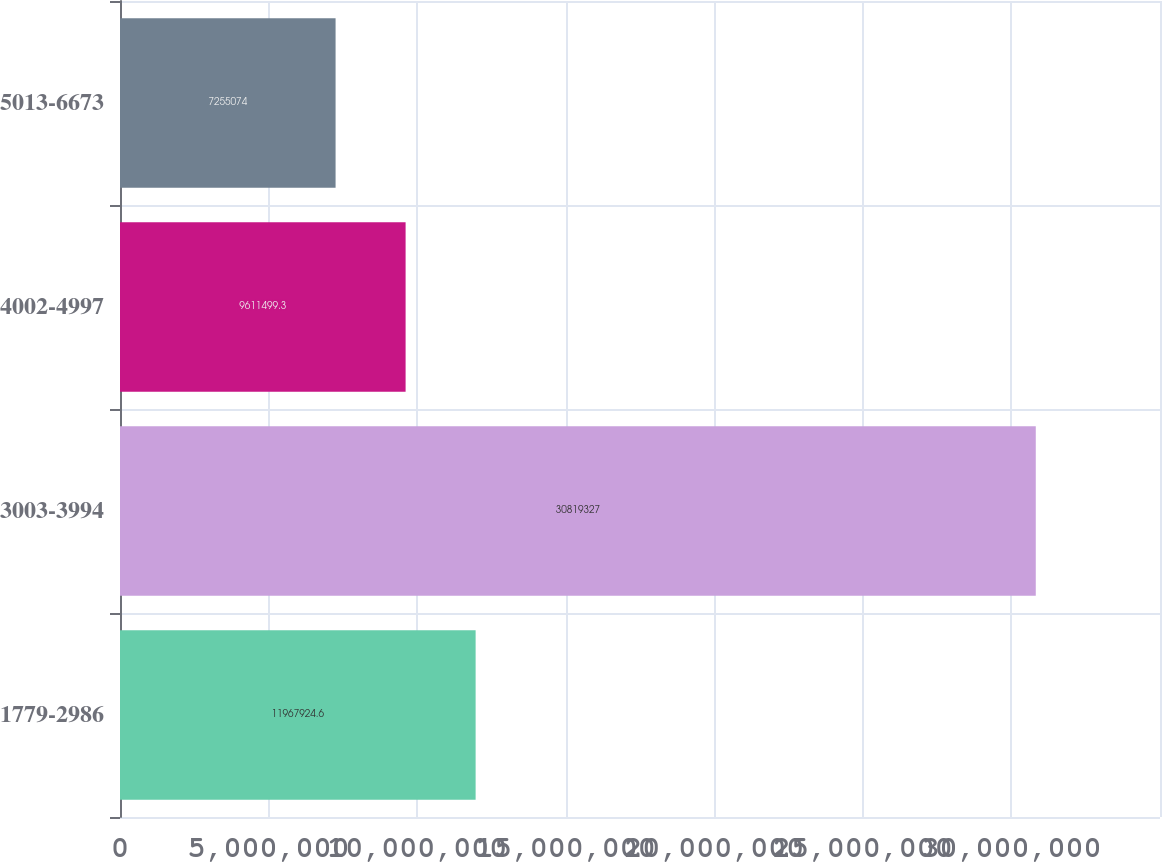Convert chart to OTSL. <chart><loc_0><loc_0><loc_500><loc_500><bar_chart><fcel>1779-2986<fcel>3003-3994<fcel>4002-4997<fcel>5013-6673<nl><fcel>1.19679e+07<fcel>3.08193e+07<fcel>9.6115e+06<fcel>7.25507e+06<nl></chart> 